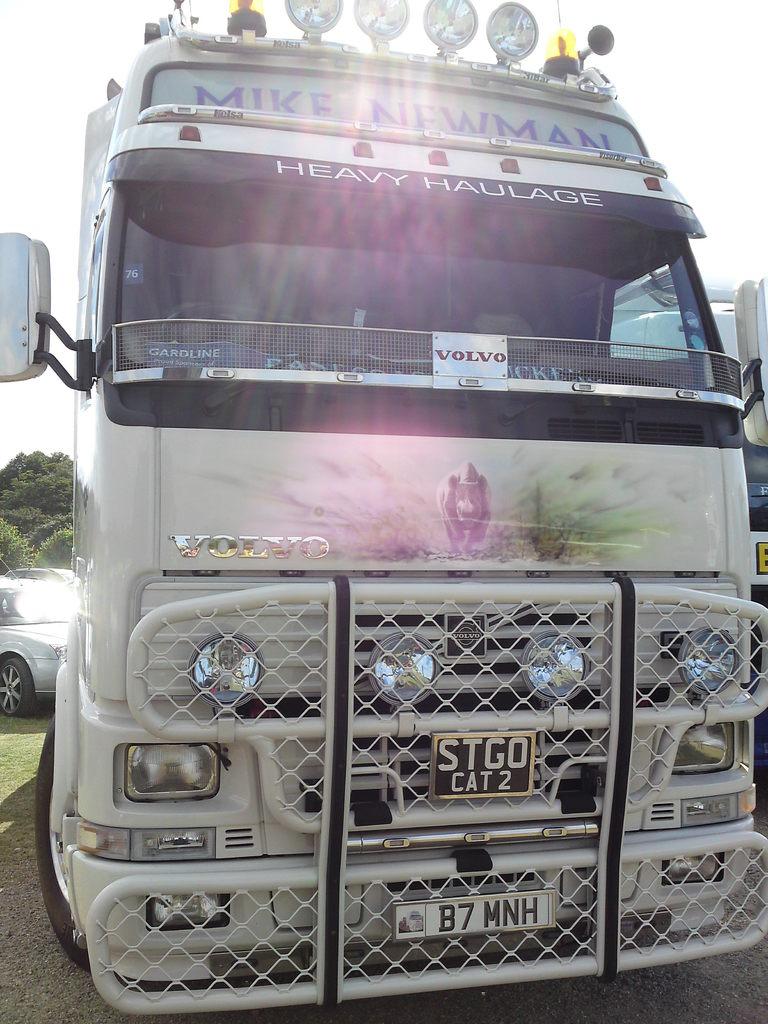What model of truck is this?
Make the answer very short. Volvo. What is the first name mentioned at the top?
Keep it short and to the point. Mike newman. 